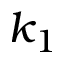<formula> <loc_0><loc_0><loc_500><loc_500>k _ { 1 }</formula> 